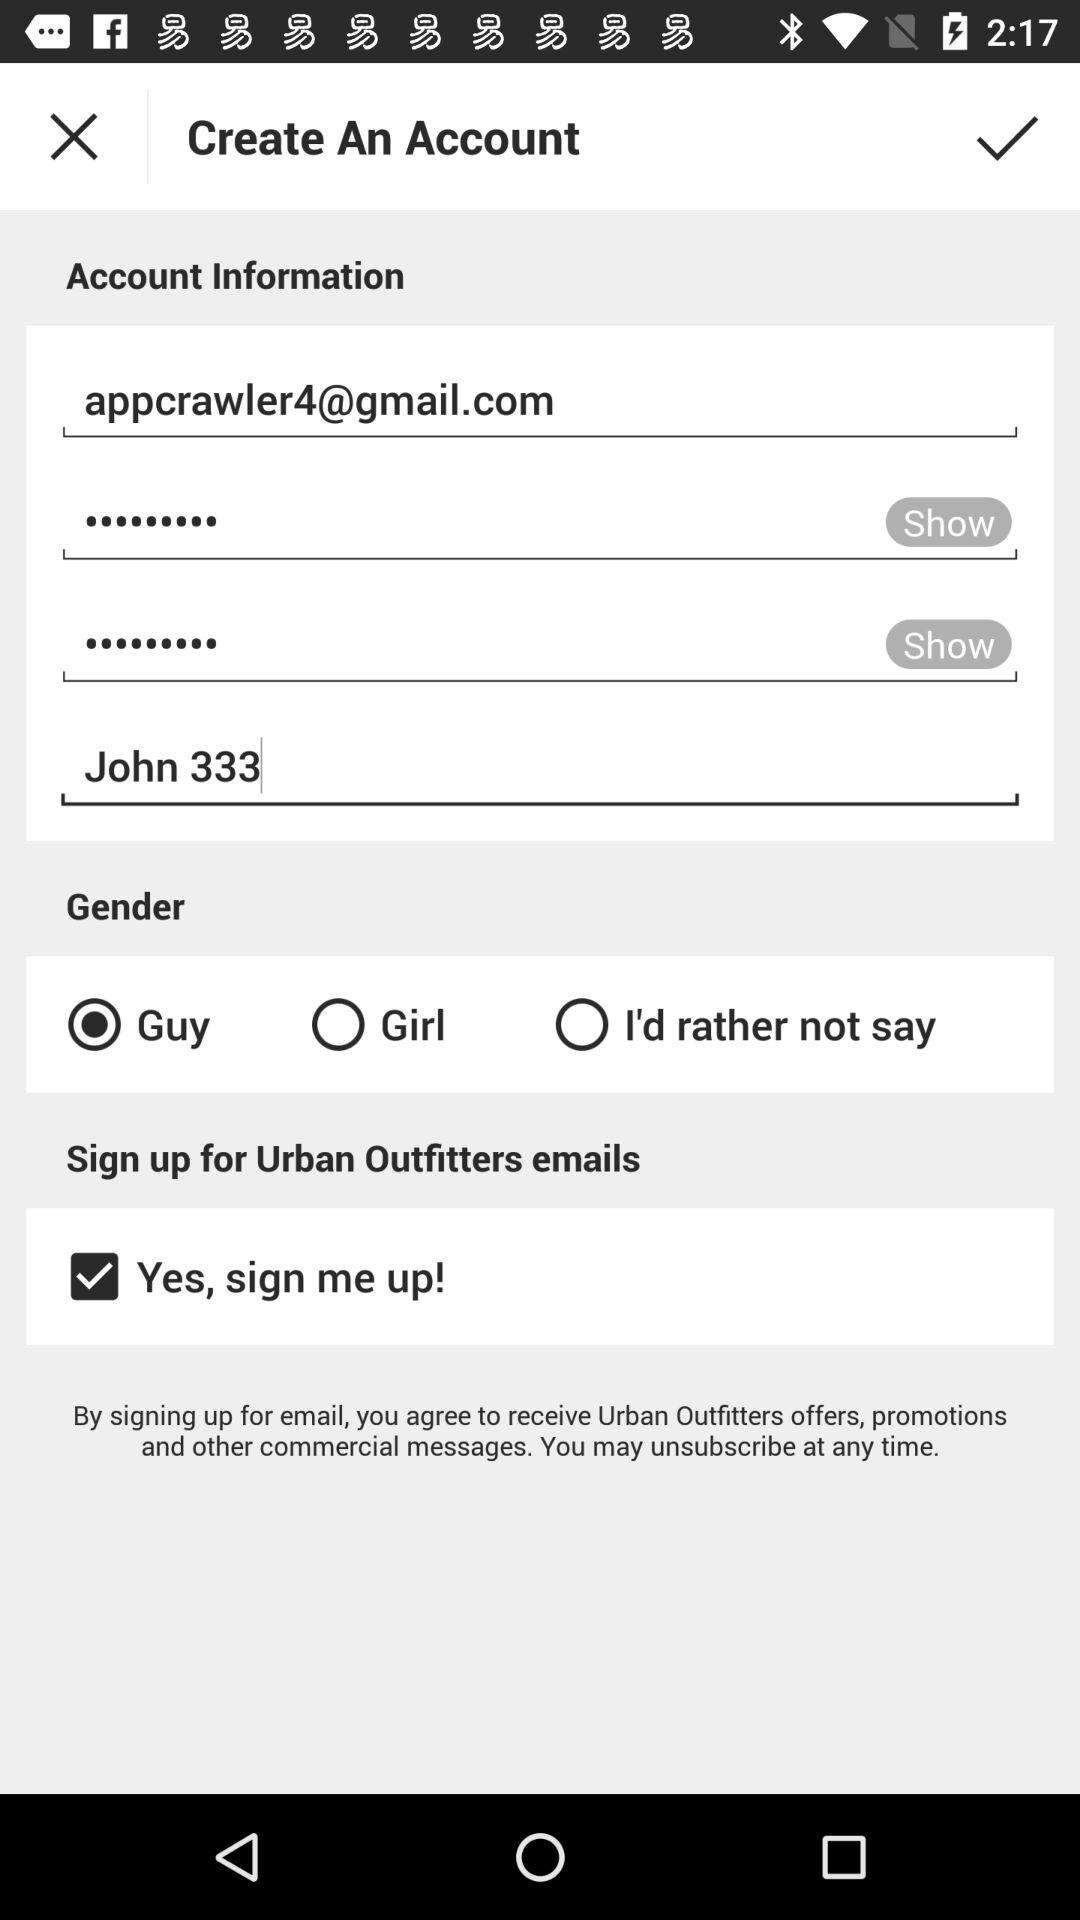What is the selected gender? The selected gender is "Guy". 